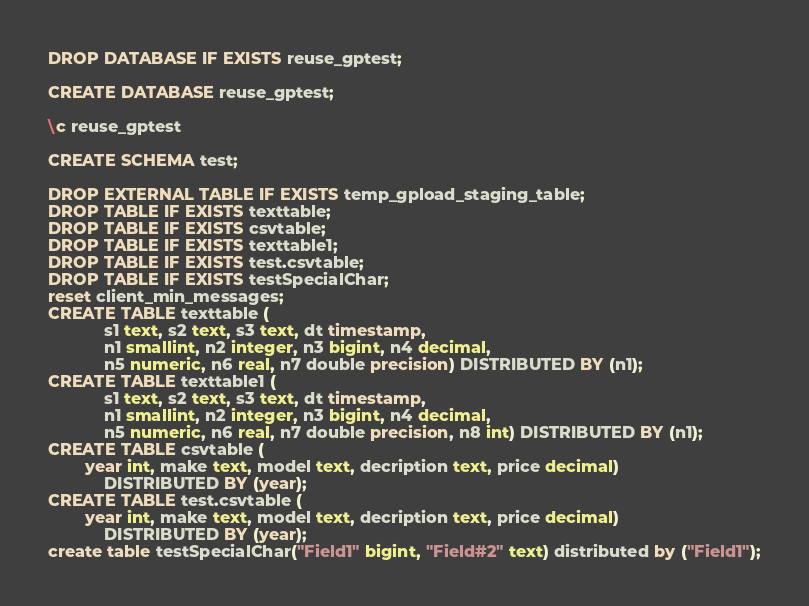Convert code to text. <code><loc_0><loc_0><loc_500><loc_500><_SQL_>DROP DATABASE IF EXISTS reuse_gptest;

CREATE DATABASE reuse_gptest;

\c reuse_gptest

CREATE SCHEMA test;

DROP EXTERNAL TABLE IF EXISTS temp_gpload_staging_table;
DROP TABLE IF EXISTS texttable;
DROP TABLE IF EXISTS csvtable;
DROP TABLE IF EXISTS texttable1;
DROP TABLE IF EXISTS test.csvtable;
DROP TABLE IF EXISTS testSpecialChar;
reset client_min_messages;
CREATE TABLE texttable (
            s1 text, s2 text, s3 text, dt timestamp,
            n1 smallint, n2 integer, n3 bigint, n4 decimal,
            n5 numeric, n6 real, n7 double precision) DISTRIBUTED BY (n1);
CREATE TABLE texttable1 (
            s1 text, s2 text, s3 text, dt timestamp,
            n1 smallint, n2 integer, n3 bigint, n4 decimal,
            n5 numeric, n6 real, n7 double precision, n8 int) DISTRIBUTED BY (n1);
CREATE TABLE csvtable (
	    year int, make text, model text, decription text, price decimal)
            DISTRIBUTED BY (year);
CREATE TABLE test.csvtable (
	    year int, make text, model text, decription text, price decimal)
            DISTRIBUTED BY (year);
create table testSpecialChar("Field1" bigint, "Field#2" text) distributed by ("Field1");
</code> 